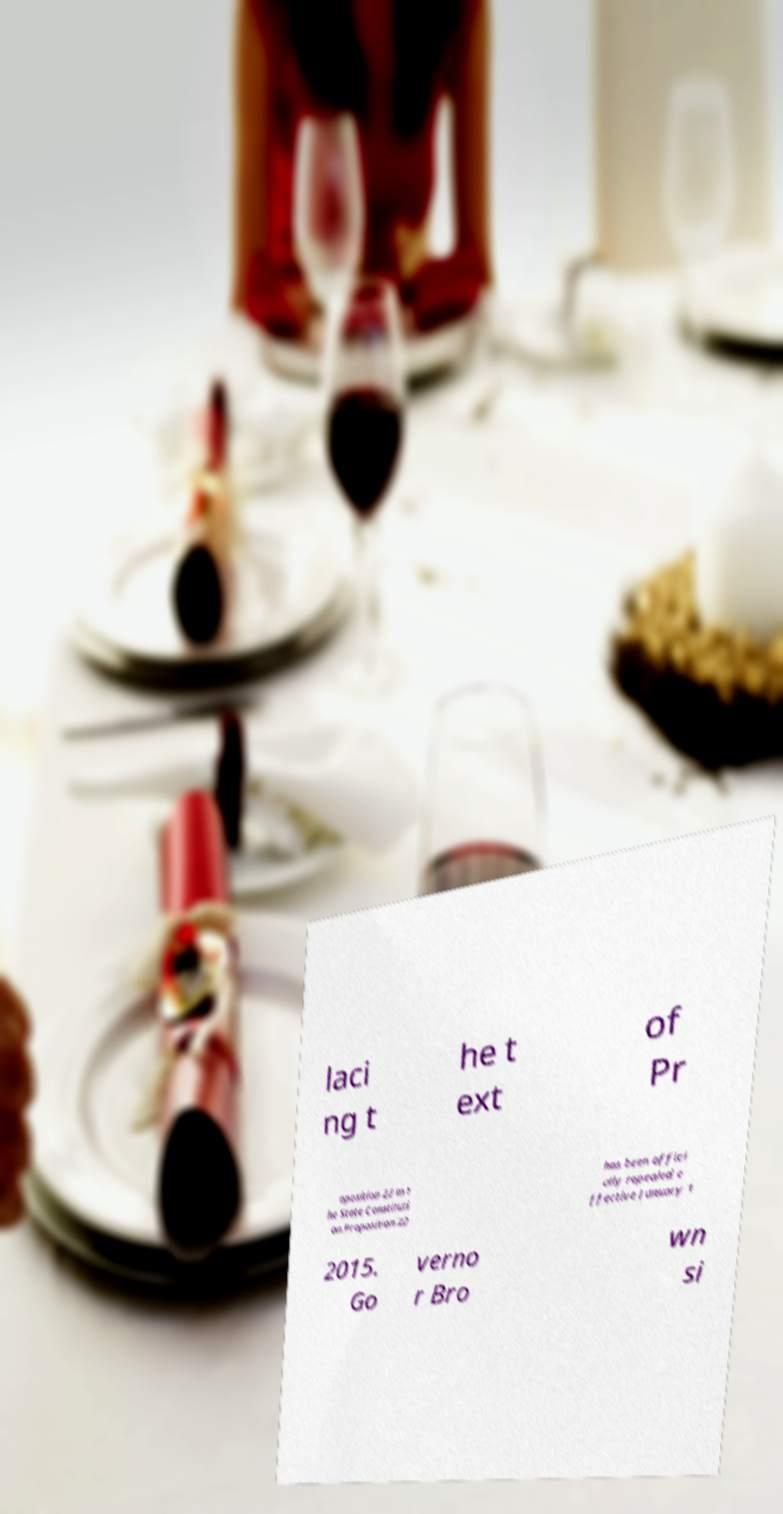Please read and relay the text visible in this image. What does it say? laci ng t he t ext of Pr oposition 22 in t he State Constituti on.Proposition 22 has been offici ally repealed e ffective January 1 2015. Go verno r Bro wn si 